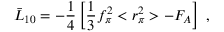<formula> <loc_0><loc_0><loc_500><loc_500>\bar { L } _ { 1 0 } = - \frac { 1 } { 4 } \left [ \frac { 1 } { 3 } f _ { \pi } ^ { 2 } < r _ { \pi } ^ { 2 } > - F _ { A } \right ] \, ,</formula> 